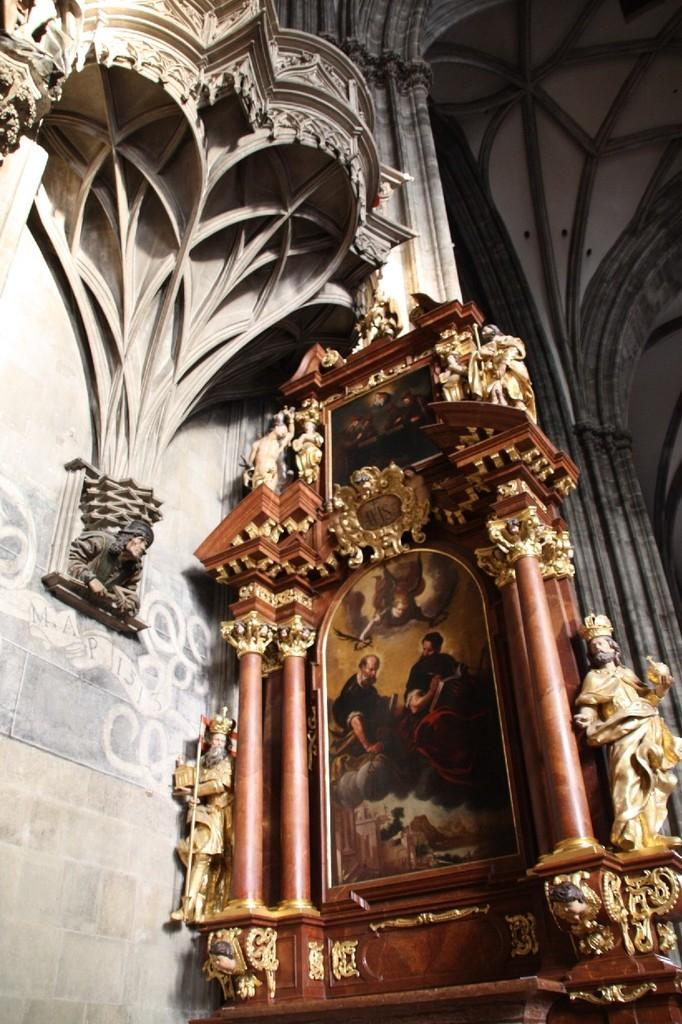What is one of the main features in the image? There is a wall in the image. What type of artwork can be seen on or near the wall? There are sculptures and a painting in the image. What is depicted in the painting? The painting contains people. What is the color of the wall in the image? The object (presumably the wall) is brown in color. How are the sculptures attached to the wall? The golden-colored sculptures are attached to the object. How many loaves of bread are stacked on top of the apples in the image? There are no loaves of bread or apples present in the image. What type of rock formation can be seen near the sculptures in the image? There is no rock formation present in the image. 